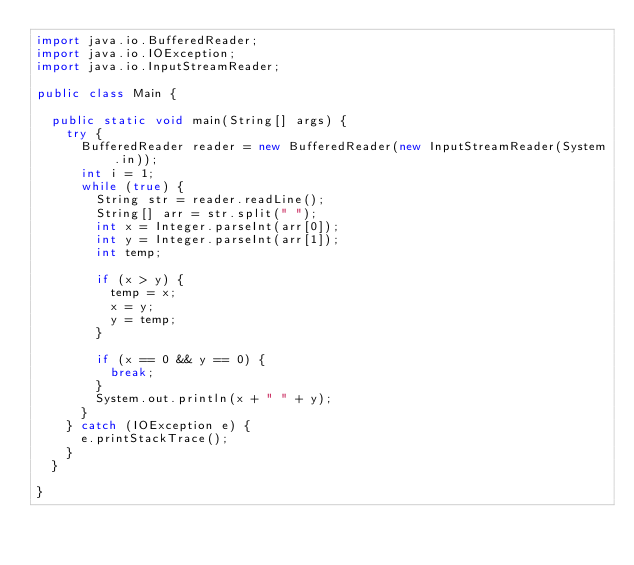Convert code to text. <code><loc_0><loc_0><loc_500><loc_500><_Java_>import java.io.BufferedReader;
import java.io.IOException;
import java.io.InputStreamReader;

public class Main {
	
	public static void main(String[] args) {
		try {
			BufferedReader reader = new BufferedReader(new InputStreamReader(System.in));
			int i = 1;
			while (true) {
				String str = reader.readLine();
				String[] arr = str.split(" ");
				int x = Integer.parseInt(arr[0]);
				int y = Integer.parseInt(arr[1]);
				int temp;
				
				if (x > y) {
					temp = x;
					x = y;
					y = temp;
				}
				
				if (x == 0 && y == 0) {
					break;
				}
				System.out.println(x + " " + y);
			}
		} catch (IOException e) {
			e.printStackTrace();
		}
	}

}</code> 